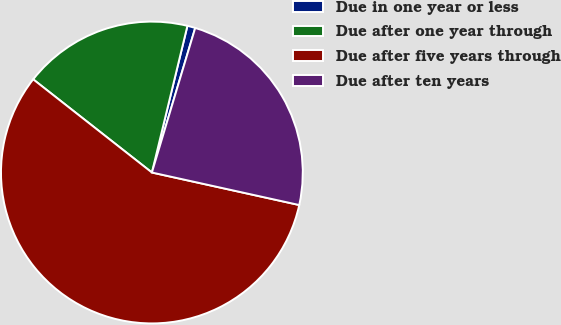Convert chart to OTSL. <chart><loc_0><loc_0><loc_500><loc_500><pie_chart><fcel>Due in one year or less<fcel>Due after one year through<fcel>Due after five years through<fcel>Due after ten years<nl><fcel>0.85%<fcel>18.19%<fcel>57.13%<fcel>23.82%<nl></chart> 